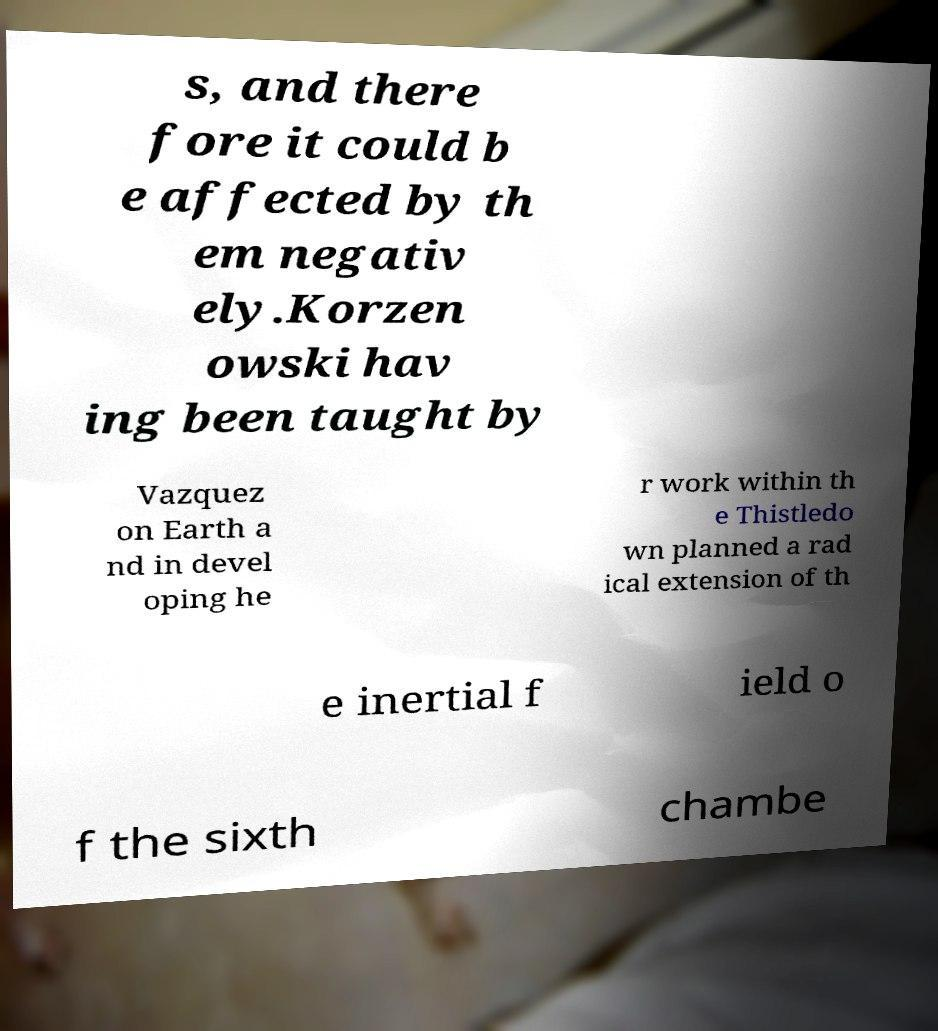Could you assist in decoding the text presented in this image and type it out clearly? s, and there fore it could b e affected by th em negativ ely.Korzen owski hav ing been taught by Vazquez on Earth a nd in devel oping he r work within th e Thistledo wn planned a rad ical extension of th e inertial f ield o f the sixth chambe 